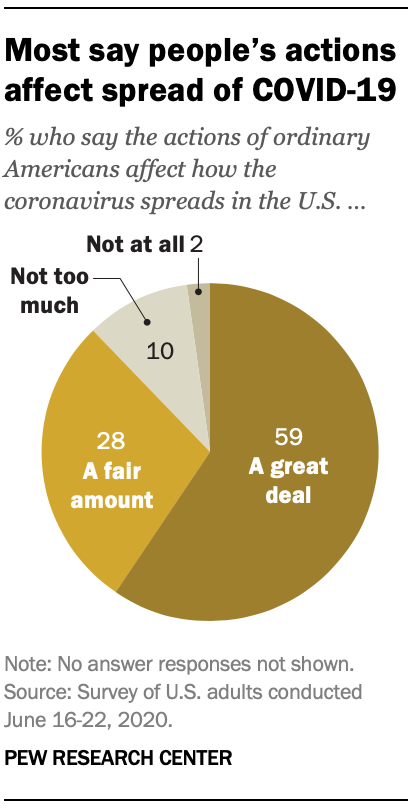Highlight a few significant elements in this photo. The value of the "Not too much" segment is between 10 and 15. It is not clear what you are asking. Can you please provide more context or clarify your question? 